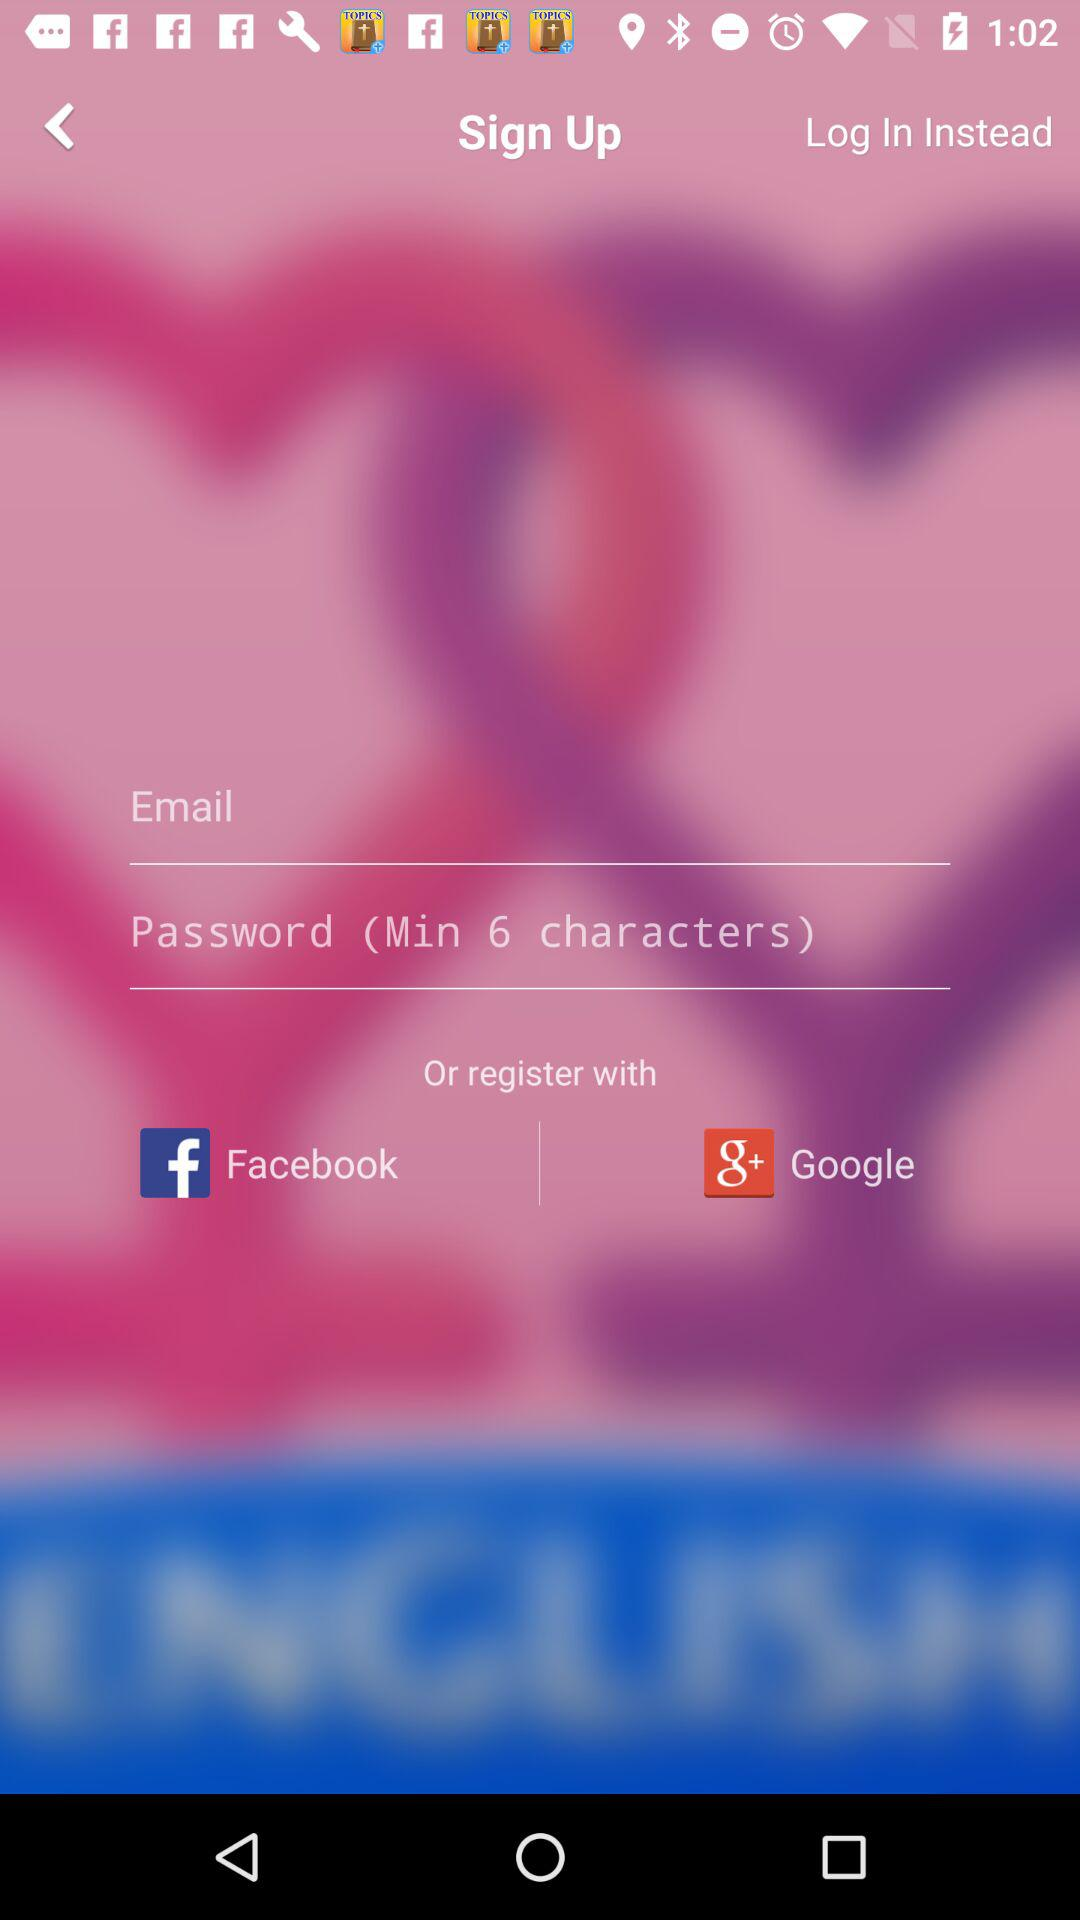How many social media options are there to register with?
Answer the question using a single word or phrase. 2 